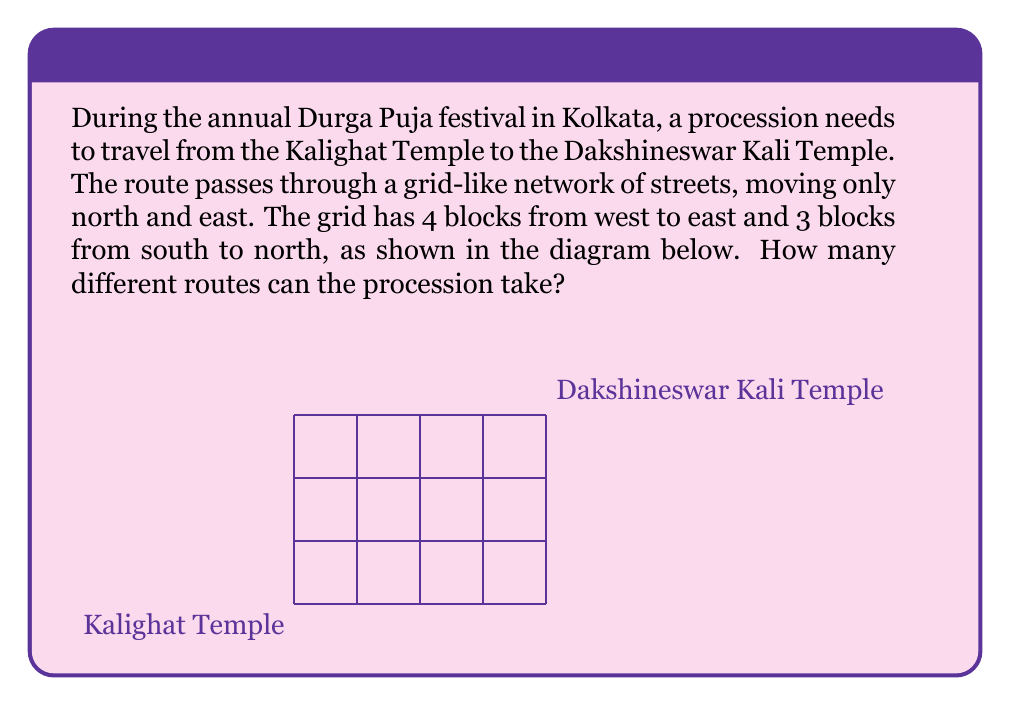Could you help me with this problem? Let's approach this step-by-step:

1) First, we need to understand what the question is asking. We're looking for the number of paths from the bottom-left corner to the top-right corner of a 4x3 grid, moving only right and up.

2) This is a classic combinatorics problem. The key insight is that any valid path must consist of exactly 4 moves to the right and 3 moves upward, in any order.

3) Therefore, we can rephrase our question: in how many ways can we arrange 4 right moves and 3 up moves?

4) This is equivalent to choosing the positions for either the right moves or the up moves out of the total 7 moves.

5) We can solve this using the combination formula. We need to choose 4 positions out of 7 for the right moves (or equivalently, 3 out of 7 for the up moves).

6) The formula for this combination is:

   $$\binom{7}{4} = \binom{7}{3} = \frac{7!}{4!(7-4)!} = \frac{7!}{4!3!}$$

7) Let's calculate this:
   
   $$\frac{7 * 6 * 5 * 4 * 3!}{4 * 3 * 2 * 1 * 3!} = \frac{7 * 6 * 5}{3 * 2 * 1} = \frac{210}{6} = 35$$

Therefore, there are 35 different routes the procession can take.
Answer: 35 